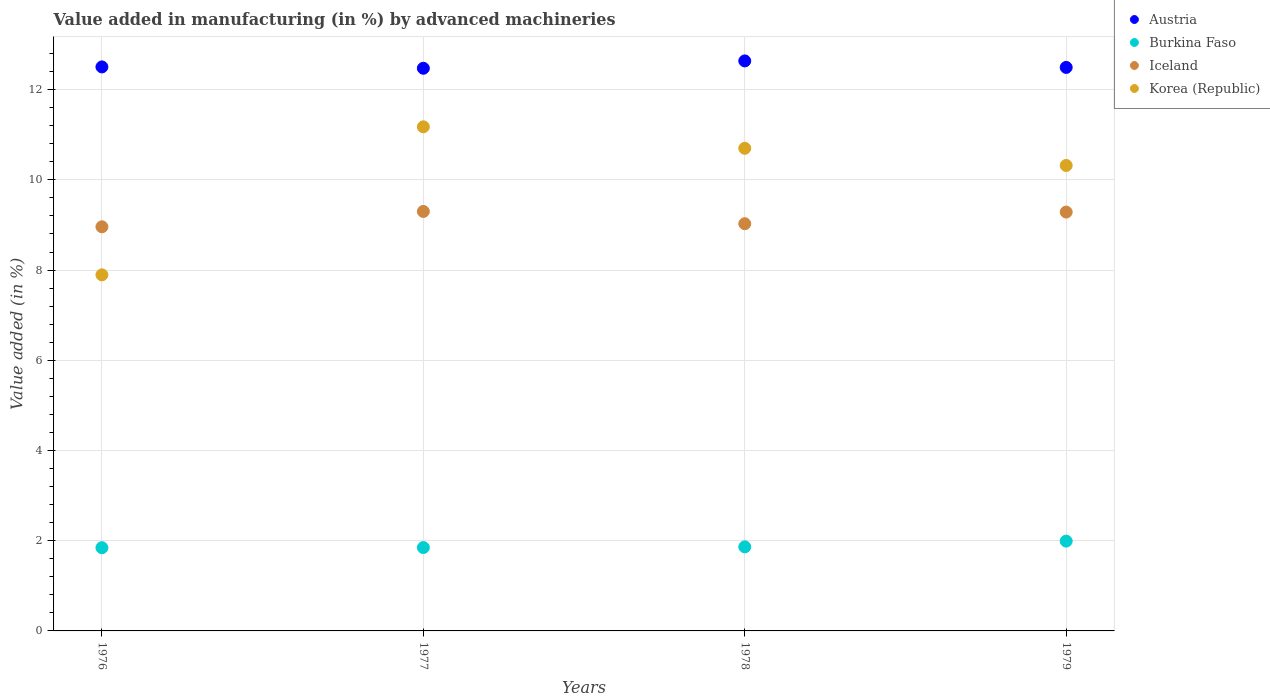How many different coloured dotlines are there?
Give a very brief answer. 4. What is the percentage of value added in manufacturing by advanced machineries in Iceland in 1979?
Provide a succinct answer. 9.29. Across all years, what is the maximum percentage of value added in manufacturing by advanced machineries in Austria?
Make the answer very short. 12.64. Across all years, what is the minimum percentage of value added in manufacturing by advanced machineries in Austria?
Make the answer very short. 12.47. In which year was the percentage of value added in manufacturing by advanced machineries in Burkina Faso maximum?
Your answer should be compact. 1979. What is the total percentage of value added in manufacturing by advanced machineries in Korea (Republic) in the graph?
Give a very brief answer. 40.09. What is the difference between the percentage of value added in manufacturing by advanced machineries in Iceland in 1977 and that in 1979?
Your response must be concise. 0.01. What is the difference between the percentage of value added in manufacturing by advanced machineries in Iceland in 1978 and the percentage of value added in manufacturing by advanced machineries in Burkina Faso in 1977?
Offer a very short reply. 7.18. What is the average percentage of value added in manufacturing by advanced machineries in Iceland per year?
Offer a very short reply. 9.14. In the year 1976, what is the difference between the percentage of value added in manufacturing by advanced machineries in Austria and percentage of value added in manufacturing by advanced machineries in Iceland?
Offer a very short reply. 3.54. In how many years, is the percentage of value added in manufacturing by advanced machineries in Austria greater than 12.4 %?
Ensure brevity in your answer.  4. What is the ratio of the percentage of value added in manufacturing by advanced machineries in Iceland in 1976 to that in 1979?
Offer a very short reply. 0.96. Is the percentage of value added in manufacturing by advanced machineries in Iceland in 1976 less than that in 1979?
Your answer should be very brief. Yes. What is the difference between the highest and the second highest percentage of value added in manufacturing by advanced machineries in Korea (Republic)?
Provide a short and direct response. 0.48. What is the difference between the highest and the lowest percentage of value added in manufacturing by advanced machineries in Burkina Faso?
Your answer should be very brief. 0.15. In how many years, is the percentage of value added in manufacturing by advanced machineries in Austria greater than the average percentage of value added in manufacturing by advanced machineries in Austria taken over all years?
Your answer should be compact. 1. Does the percentage of value added in manufacturing by advanced machineries in Korea (Republic) monotonically increase over the years?
Provide a short and direct response. No. Is the percentage of value added in manufacturing by advanced machineries in Iceland strictly greater than the percentage of value added in manufacturing by advanced machineries in Burkina Faso over the years?
Provide a short and direct response. Yes. Is the percentage of value added in manufacturing by advanced machineries in Austria strictly less than the percentage of value added in manufacturing by advanced machineries in Korea (Republic) over the years?
Ensure brevity in your answer.  No. How many dotlines are there?
Provide a short and direct response. 4. What is the difference between two consecutive major ticks on the Y-axis?
Your answer should be very brief. 2. Does the graph contain any zero values?
Provide a succinct answer. No. Does the graph contain grids?
Your answer should be very brief. Yes. How many legend labels are there?
Your response must be concise. 4. How are the legend labels stacked?
Give a very brief answer. Vertical. What is the title of the graph?
Your answer should be compact. Value added in manufacturing (in %) by advanced machineries. What is the label or title of the X-axis?
Your answer should be very brief. Years. What is the label or title of the Y-axis?
Your answer should be compact. Value added (in %). What is the Value added (in %) of Austria in 1976?
Your answer should be very brief. 12.5. What is the Value added (in %) in Burkina Faso in 1976?
Your answer should be compact. 1.85. What is the Value added (in %) in Iceland in 1976?
Offer a terse response. 8.96. What is the Value added (in %) in Korea (Republic) in 1976?
Your answer should be compact. 7.89. What is the Value added (in %) of Austria in 1977?
Offer a terse response. 12.47. What is the Value added (in %) in Burkina Faso in 1977?
Ensure brevity in your answer.  1.85. What is the Value added (in %) in Iceland in 1977?
Provide a succinct answer. 9.3. What is the Value added (in %) in Korea (Republic) in 1977?
Offer a terse response. 11.18. What is the Value added (in %) in Austria in 1978?
Provide a succinct answer. 12.64. What is the Value added (in %) in Burkina Faso in 1978?
Your response must be concise. 1.86. What is the Value added (in %) of Iceland in 1978?
Make the answer very short. 9.03. What is the Value added (in %) of Korea (Republic) in 1978?
Give a very brief answer. 10.7. What is the Value added (in %) in Austria in 1979?
Your response must be concise. 12.49. What is the Value added (in %) of Burkina Faso in 1979?
Your answer should be very brief. 1.99. What is the Value added (in %) in Iceland in 1979?
Provide a short and direct response. 9.29. What is the Value added (in %) in Korea (Republic) in 1979?
Keep it short and to the point. 10.32. Across all years, what is the maximum Value added (in %) in Austria?
Your answer should be compact. 12.64. Across all years, what is the maximum Value added (in %) of Burkina Faso?
Provide a short and direct response. 1.99. Across all years, what is the maximum Value added (in %) in Iceland?
Give a very brief answer. 9.3. Across all years, what is the maximum Value added (in %) of Korea (Republic)?
Offer a very short reply. 11.18. Across all years, what is the minimum Value added (in %) of Austria?
Ensure brevity in your answer.  12.47. Across all years, what is the minimum Value added (in %) of Burkina Faso?
Your answer should be compact. 1.85. Across all years, what is the minimum Value added (in %) of Iceland?
Provide a short and direct response. 8.96. Across all years, what is the minimum Value added (in %) in Korea (Republic)?
Provide a succinct answer. 7.89. What is the total Value added (in %) in Austria in the graph?
Your response must be concise. 50.11. What is the total Value added (in %) of Burkina Faso in the graph?
Give a very brief answer. 7.55. What is the total Value added (in %) in Iceland in the graph?
Provide a short and direct response. 36.57. What is the total Value added (in %) of Korea (Republic) in the graph?
Your response must be concise. 40.09. What is the difference between the Value added (in %) of Austria in 1976 and that in 1977?
Offer a terse response. 0.03. What is the difference between the Value added (in %) of Burkina Faso in 1976 and that in 1977?
Provide a succinct answer. -0. What is the difference between the Value added (in %) in Iceland in 1976 and that in 1977?
Keep it short and to the point. -0.34. What is the difference between the Value added (in %) of Korea (Republic) in 1976 and that in 1977?
Provide a succinct answer. -3.28. What is the difference between the Value added (in %) in Austria in 1976 and that in 1978?
Your answer should be compact. -0.13. What is the difference between the Value added (in %) of Burkina Faso in 1976 and that in 1978?
Offer a very short reply. -0.02. What is the difference between the Value added (in %) in Iceland in 1976 and that in 1978?
Make the answer very short. -0.07. What is the difference between the Value added (in %) of Korea (Republic) in 1976 and that in 1978?
Your response must be concise. -2.81. What is the difference between the Value added (in %) in Austria in 1976 and that in 1979?
Provide a succinct answer. 0.01. What is the difference between the Value added (in %) in Burkina Faso in 1976 and that in 1979?
Your response must be concise. -0.15. What is the difference between the Value added (in %) in Iceland in 1976 and that in 1979?
Give a very brief answer. -0.33. What is the difference between the Value added (in %) of Korea (Republic) in 1976 and that in 1979?
Your answer should be compact. -2.42. What is the difference between the Value added (in %) of Austria in 1977 and that in 1978?
Offer a very short reply. -0.16. What is the difference between the Value added (in %) in Burkina Faso in 1977 and that in 1978?
Ensure brevity in your answer.  -0.02. What is the difference between the Value added (in %) in Iceland in 1977 and that in 1978?
Your answer should be very brief. 0.27. What is the difference between the Value added (in %) of Korea (Republic) in 1977 and that in 1978?
Provide a succinct answer. 0.48. What is the difference between the Value added (in %) of Austria in 1977 and that in 1979?
Offer a very short reply. -0.02. What is the difference between the Value added (in %) in Burkina Faso in 1977 and that in 1979?
Offer a very short reply. -0.14. What is the difference between the Value added (in %) in Iceland in 1977 and that in 1979?
Your answer should be very brief. 0.01. What is the difference between the Value added (in %) in Korea (Republic) in 1977 and that in 1979?
Make the answer very short. 0.86. What is the difference between the Value added (in %) of Austria in 1978 and that in 1979?
Your answer should be compact. 0.14. What is the difference between the Value added (in %) of Burkina Faso in 1978 and that in 1979?
Your answer should be compact. -0.13. What is the difference between the Value added (in %) in Iceland in 1978 and that in 1979?
Your answer should be compact. -0.26. What is the difference between the Value added (in %) in Korea (Republic) in 1978 and that in 1979?
Give a very brief answer. 0.38. What is the difference between the Value added (in %) in Austria in 1976 and the Value added (in %) in Burkina Faso in 1977?
Your answer should be very brief. 10.66. What is the difference between the Value added (in %) in Austria in 1976 and the Value added (in %) in Iceland in 1977?
Your answer should be very brief. 3.2. What is the difference between the Value added (in %) of Austria in 1976 and the Value added (in %) of Korea (Republic) in 1977?
Your answer should be very brief. 1.33. What is the difference between the Value added (in %) of Burkina Faso in 1976 and the Value added (in %) of Iceland in 1977?
Your answer should be compact. -7.45. What is the difference between the Value added (in %) of Burkina Faso in 1976 and the Value added (in %) of Korea (Republic) in 1977?
Give a very brief answer. -9.33. What is the difference between the Value added (in %) of Iceland in 1976 and the Value added (in %) of Korea (Republic) in 1977?
Give a very brief answer. -2.22. What is the difference between the Value added (in %) of Austria in 1976 and the Value added (in %) of Burkina Faso in 1978?
Your response must be concise. 10.64. What is the difference between the Value added (in %) in Austria in 1976 and the Value added (in %) in Iceland in 1978?
Your answer should be very brief. 3.48. What is the difference between the Value added (in %) in Austria in 1976 and the Value added (in %) in Korea (Republic) in 1978?
Offer a very short reply. 1.8. What is the difference between the Value added (in %) of Burkina Faso in 1976 and the Value added (in %) of Iceland in 1978?
Your answer should be compact. -7.18. What is the difference between the Value added (in %) of Burkina Faso in 1976 and the Value added (in %) of Korea (Republic) in 1978?
Your answer should be very brief. -8.85. What is the difference between the Value added (in %) of Iceland in 1976 and the Value added (in %) of Korea (Republic) in 1978?
Offer a very short reply. -1.74. What is the difference between the Value added (in %) of Austria in 1976 and the Value added (in %) of Burkina Faso in 1979?
Offer a terse response. 10.51. What is the difference between the Value added (in %) in Austria in 1976 and the Value added (in %) in Iceland in 1979?
Provide a short and direct response. 3.22. What is the difference between the Value added (in %) of Austria in 1976 and the Value added (in %) of Korea (Republic) in 1979?
Your answer should be very brief. 2.18. What is the difference between the Value added (in %) of Burkina Faso in 1976 and the Value added (in %) of Iceland in 1979?
Your answer should be compact. -7.44. What is the difference between the Value added (in %) in Burkina Faso in 1976 and the Value added (in %) in Korea (Republic) in 1979?
Your answer should be very brief. -8.47. What is the difference between the Value added (in %) of Iceland in 1976 and the Value added (in %) of Korea (Republic) in 1979?
Make the answer very short. -1.36. What is the difference between the Value added (in %) of Austria in 1977 and the Value added (in %) of Burkina Faso in 1978?
Give a very brief answer. 10.61. What is the difference between the Value added (in %) of Austria in 1977 and the Value added (in %) of Iceland in 1978?
Provide a succinct answer. 3.45. What is the difference between the Value added (in %) of Austria in 1977 and the Value added (in %) of Korea (Republic) in 1978?
Keep it short and to the point. 1.77. What is the difference between the Value added (in %) in Burkina Faso in 1977 and the Value added (in %) in Iceland in 1978?
Ensure brevity in your answer.  -7.18. What is the difference between the Value added (in %) in Burkina Faso in 1977 and the Value added (in %) in Korea (Republic) in 1978?
Your answer should be compact. -8.85. What is the difference between the Value added (in %) in Iceland in 1977 and the Value added (in %) in Korea (Republic) in 1978?
Offer a terse response. -1.4. What is the difference between the Value added (in %) of Austria in 1977 and the Value added (in %) of Burkina Faso in 1979?
Provide a short and direct response. 10.48. What is the difference between the Value added (in %) in Austria in 1977 and the Value added (in %) in Iceland in 1979?
Offer a terse response. 3.19. What is the difference between the Value added (in %) of Austria in 1977 and the Value added (in %) of Korea (Republic) in 1979?
Provide a short and direct response. 2.15. What is the difference between the Value added (in %) of Burkina Faso in 1977 and the Value added (in %) of Iceland in 1979?
Offer a terse response. -7.44. What is the difference between the Value added (in %) in Burkina Faso in 1977 and the Value added (in %) in Korea (Republic) in 1979?
Offer a terse response. -8.47. What is the difference between the Value added (in %) of Iceland in 1977 and the Value added (in %) of Korea (Republic) in 1979?
Your answer should be very brief. -1.02. What is the difference between the Value added (in %) in Austria in 1978 and the Value added (in %) in Burkina Faso in 1979?
Ensure brevity in your answer.  10.65. What is the difference between the Value added (in %) of Austria in 1978 and the Value added (in %) of Iceland in 1979?
Offer a terse response. 3.35. What is the difference between the Value added (in %) in Austria in 1978 and the Value added (in %) in Korea (Republic) in 1979?
Provide a short and direct response. 2.32. What is the difference between the Value added (in %) of Burkina Faso in 1978 and the Value added (in %) of Iceland in 1979?
Provide a short and direct response. -7.42. What is the difference between the Value added (in %) in Burkina Faso in 1978 and the Value added (in %) in Korea (Republic) in 1979?
Your answer should be very brief. -8.46. What is the difference between the Value added (in %) in Iceland in 1978 and the Value added (in %) in Korea (Republic) in 1979?
Make the answer very short. -1.29. What is the average Value added (in %) of Austria per year?
Your response must be concise. 12.53. What is the average Value added (in %) of Burkina Faso per year?
Offer a very short reply. 1.89. What is the average Value added (in %) in Iceland per year?
Your response must be concise. 9.14. What is the average Value added (in %) in Korea (Republic) per year?
Keep it short and to the point. 10.02. In the year 1976, what is the difference between the Value added (in %) in Austria and Value added (in %) in Burkina Faso?
Give a very brief answer. 10.66. In the year 1976, what is the difference between the Value added (in %) of Austria and Value added (in %) of Iceland?
Provide a short and direct response. 3.54. In the year 1976, what is the difference between the Value added (in %) in Austria and Value added (in %) in Korea (Republic)?
Provide a short and direct response. 4.61. In the year 1976, what is the difference between the Value added (in %) in Burkina Faso and Value added (in %) in Iceland?
Keep it short and to the point. -7.11. In the year 1976, what is the difference between the Value added (in %) of Burkina Faso and Value added (in %) of Korea (Republic)?
Provide a short and direct response. -6.05. In the year 1976, what is the difference between the Value added (in %) in Iceland and Value added (in %) in Korea (Republic)?
Offer a very short reply. 1.07. In the year 1977, what is the difference between the Value added (in %) in Austria and Value added (in %) in Burkina Faso?
Ensure brevity in your answer.  10.63. In the year 1977, what is the difference between the Value added (in %) in Austria and Value added (in %) in Iceland?
Offer a terse response. 3.17. In the year 1977, what is the difference between the Value added (in %) in Austria and Value added (in %) in Korea (Republic)?
Your response must be concise. 1.3. In the year 1977, what is the difference between the Value added (in %) in Burkina Faso and Value added (in %) in Iceland?
Keep it short and to the point. -7.45. In the year 1977, what is the difference between the Value added (in %) of Burkina Faso and Value added (in %) of Korea (Republic)?
Your answer should be compact. -9.33. In the year 1977, what is the difference between the Value added (in %) in Iceland and Value added (in %) in Korea (Republic)?
Provide a short and direct response. -1.88. In the year 1978, what is the difference between the Value added (in %) in Austria and Value added (in %) in Burkina Faso?
Provide a short and direct response. 10.77. In the year 1978, what is the difference between the Value added (in %) of Austria and Value added (in %) of Iceland?
Ensure brevity in your answer.  3.61. In the year 1978, what is the difference between the Value added (in %) in Austria and Value added (in %) in Korea (Republic)?
Ensure brevity in your answer.  1.94. In the year 1978, what is the difference between the Value added (in %) in Burkina Faso and Value added (in %) in Iceland?
Give a very brief answer. -7.16. In the year 1978, what is the difference between the Value added (in %) of Burkina Faso and Value added (in %) of Korea (Republic)?
Make the answer very short. -8.84. In the year 1978, what is the difference between the Value added (in %) in Iceland and Value added (in %) in Korea (Republic)?
Your answer should be compact. -1.67. In the year 1979, what is the difference between the Value added (in %) of Austria and Value added (in %) of Burkina Faso?
Your answer should be very brief. 10.5. In the year 1979, what is the difference between the Value added (in %) of Austria and Value added (in %) of Iceland?
Keep it short and to the point. 3.21. In the year 1979, what is the difference between the Value added (in %) of Austria and Value added (in %) of Korea (Republic)?
Your answer should be very brief. 2.17. In the year 1979, what is the difference between the Value added (in %) in Burkina Faso and Value added (in %) in Iceland?
Your response must be concise. -7.29. In the year 1979, what is the difference between the Value added (in %) in Burkina Faso and Value added (in %) in Korea (Republic)?
Offer a very short reply. -8.33. In the year 1979, what is the difference between the Value added (in %) in Iceland and Value added (in %) in Korea (Republic)?
Keep it short and to the point. -1.03. What is the ratio of the Value added (in %) in Burkina Faso in 1976 to that in 1977?
Offer a very short reply. 1. What is the ratio of the Value added (in %) of Iceland in 1976 to that in 1977?
Your answer should be compact. 0.96. What is the ratio of the Value added (in %) of Korea (Republic) in 1976 to that in 1977?
Your response must be concise. 0.71. What is the ratio of the Value added (in %) of Austria in 1976 to that in 1978?
Ensure brevity in your answer.  0.99. What is the ratio of the Value added (in %) in Burkina Faso in 1976 to that in 1978?
Your response must be concise. 0.99. What is the ratio of the Value added (in %) of Iceland in 1976 to that in 1978?
Provide a short and direct response. 0.99. What is the ratio of the Value added (in %) in Korea (Republic) in 1976 to that in 1978?
Provide a short and direct response. 0.74. What is the ratio of the Value added (in %) of Austria in 1976 to that in 1979?
Ensure brevity in your answer.  1. What is the ratio of the Value added (in %) of Burkina Faso in 1976 to that in 1979?
Your answer should be compact. 0.93. What is the ratio of the Value added (in %) of Iceland in 1976 to that in 1979?
Your answer should be compact. 0.96. What is the ratio of the Value added (in %) of Korea (Republic) in 1976 to that in 1979?
Give a very brief answer. 0.77. What is the ratio of the Value added (in %) in Austria in 1977 to that in 1978?
Your answer should be compact. 0.99. What is the ratio of the Value added (in %) of Burkina Faso in 1977 to that in 1978?
Ensure brevity in your answer.  0.99. What is the ratio of the Value added (in %) of Iceland in 1977 to that in 1978?
Provide a succinct answer. 1.03. What is the ratio of the Value added (in %) in Korea (Republic) in 1977 to that in 1978?
Keep it short and to the point. 1.04. What is the ratio of the Value added (in %) of Burkina Faso in 1977 to that in 1979?
Give a very brief answer. 0.93. What is the ratio of the Value added (in %) in Korea (Republic) in 1977 to that in 1979?
Offer a terse response. 1.08. What is the ratio of the Value added (in %) in Austria in 1978 to that in 1979?
Your answer should be compact. 1.01. What is the ratio of the Value added (in %) in Burkina Faso in 1978 to that in 1979?
Give a very brief answer. 0.94. What is the ratio of the Value added (in %) in Iceland in 1978 to that in 1979?
Your answer should be very brief. 0.97. What is the ratio of the Value added (in %) of Korea (Republic) in 1978 to that in 1979?
Your answer should be very brief. 1.04. What is the difference between the highest and the second highest Value added (in %) of Austria?
Provide a succinct answer. 0.13. What is the difference between the highest and the second highest Value added (in %) of Burkina Faso?
Your response must be concise. 0.13. What is the difference between the highest and the second highest Value added (in %) in Iceland?
Offer a terse response. 0.01. What is the difference between the highest and the second highest Value added (in %) in Korea (Republic)?
Keep it short and to the point. 0.48. What is the difference between the highest and the lowest Value added (in %) in Austria?
Your answer should be compact. 0.16. What is the difference between the highest and the lowest Value added (in %) in Burkina Faso?
Ensure brevity in your answer.  0.15. What is the difference between the highest and the lowest Value added (in %) in Iceland?
Keep it short and to the point. 0.34. What is the difference between the highest and the lowest Value added (in %) in Korea (Republic)?
Your answer should be very brief. 3.28. 